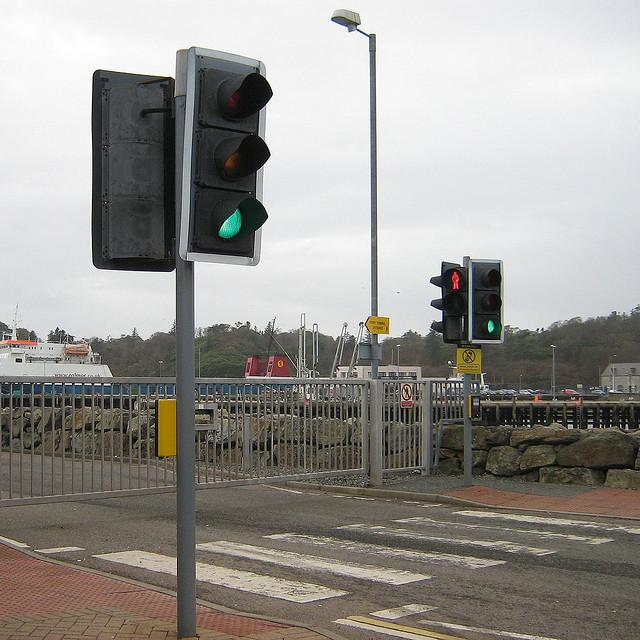What type of surface can be found past the rock wall to the right of the road? water 